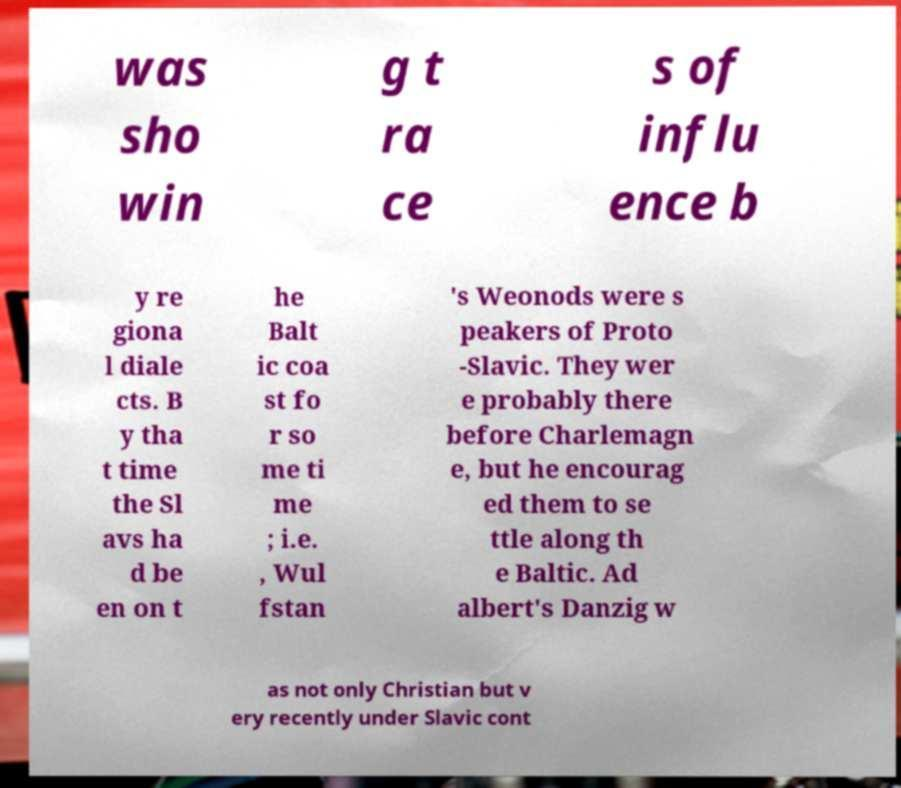I need the written content from this picture converted into text. Can you do that? was sho win g t ra ce s of influ ence b y re giona l diale cts. B y tha t time the Sl avs ha d be en on t he Balt ic coa st fo r so me ti me ; i.e. , Wul fstan 's Weonods were s peakers of Proto -Slavic. They wer e probably there before Charlemagn e, but he encourag ed them to se ttle along th e Baltic. Ad albert's Danzig w as not only Christian but v ery recently under Slavic cont 